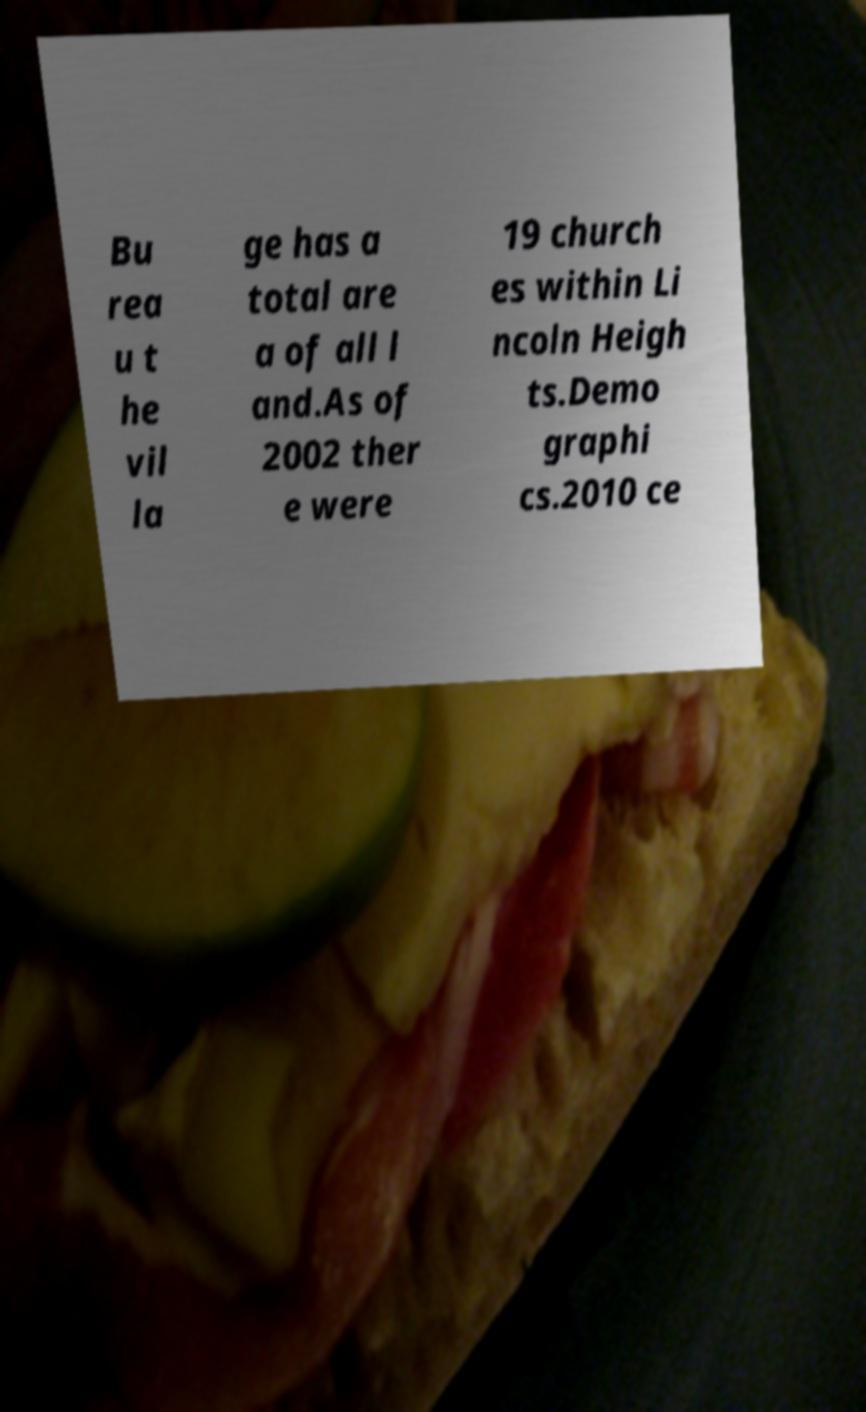Can you accurately transcribe the text from the provided image for me? Bu rea u t he vil la ge has a total are a of all l and.As of 2002 ther e were 19 church es within Li ncoln Heigh ts.Demo graphi cs.2010 ce 